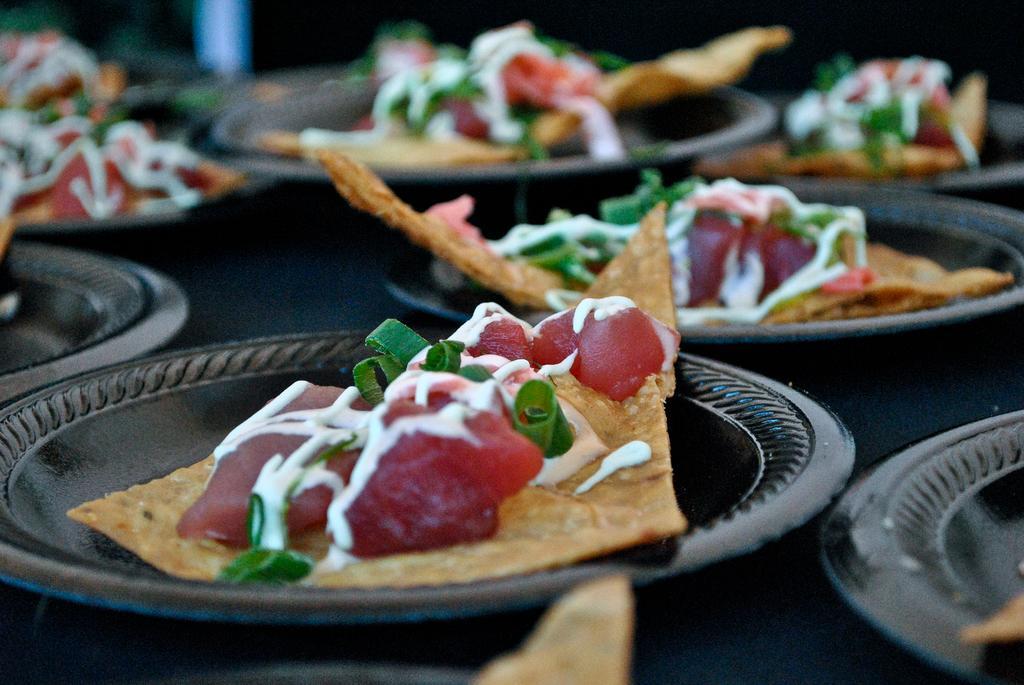Please provide a concise description of this image. In this picture I can see food in the plates. looks like nachos. 